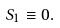<formula> <loc_0><loc_0><loc_500><loc_500>S _ { 1 } \equiv 0 .</formula> 